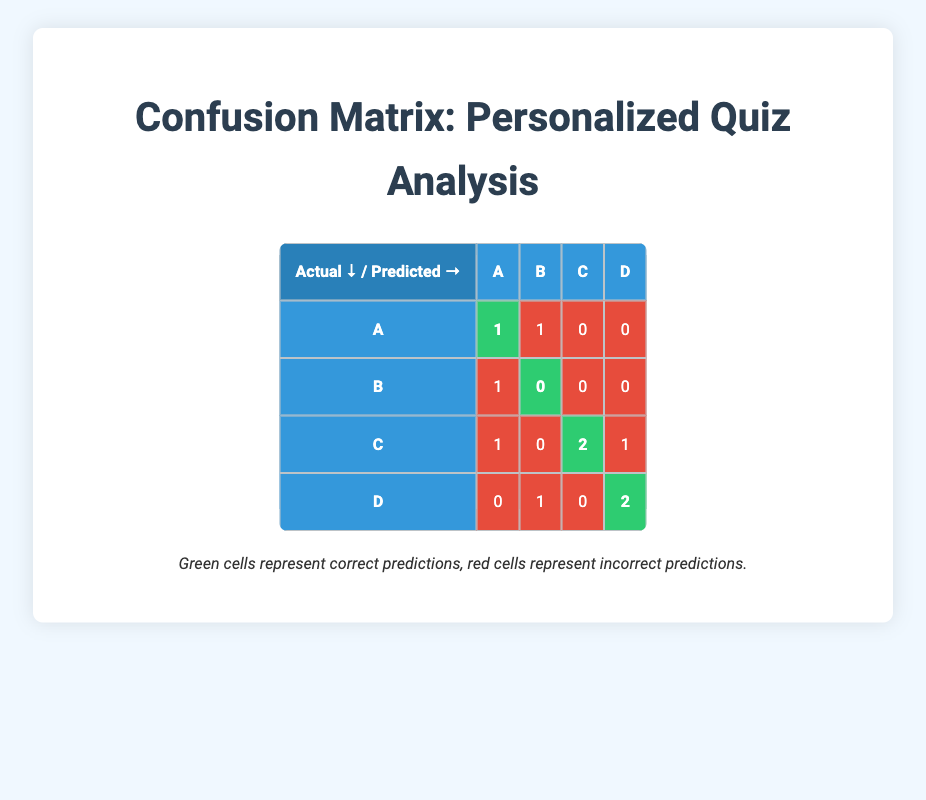What is the total number of correct predictions? To find the total number of correct predictions, we can sum up the values in the green cells of the confusion matrix. These are 1 from row A, 1 from row B, 2 from row C, and 2 from row D. Thus, the total is 1 + 1 + 2 + 2 = 6.
Answer: 6 How many questions did students answer incorrectly with the predicted answer as A? Inspecting the row for predicted answer A, we see that there is 1 incorrect prediction for actual answer B and 1 for actual answer C. Adding these gives us a total of 2 incorrect predictions.
Answer: 2 What percentage of questions were answered correctly for the actual answer C? First, we need to find the total number of instances where the actual answer was C. This is shown as the sum of all values in the row for actual answer C, which is 1 (incorrect with predicted A) + 0 (incorrect with predicted B) + 2 (correct with predicted C) + 1 (incorrect with predicted D) = 4. The correct answers (green cell) are 2. The percentage is calculated as (correct/total) * 100 = (2/4) * 100 = 50.
Answer: 50 Is it true that no questions were answered correctly with predicted answer B? Looking at the row for predicted answer B, we find that there are no green cells (correct predictions) in that entire row. This means that all predictions with B were incorrect, confirming that it is true.
Answer: Yes Which actual answer has the highest number of incorrect predictions? To determine which actual answer has the most incorrect predictions, we sum the red cells for each row: For A, it's 1 (predicted B) + 1 (predicted A) = 2; for B, it's 1 (predicted A) = 1; for C, it's 1 (predicted A) + 1 (predicted D) = 2; and for D, it's 1 (predicted B) = 1. The maximum value here is 2 for both A and C, indicating they are tied.
Answer: A and C 